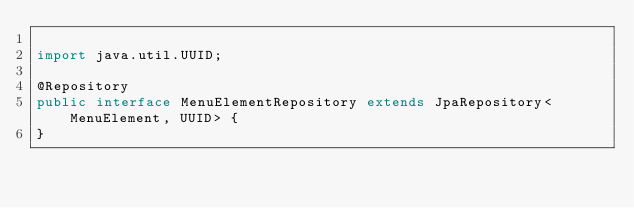<code> <loc_0><loc_0><loc_500><loc_500><_Java_>
import java.util.UUID;

@Repository
public interface MenuElementRepository extends JpaRepository<MenuElement, UUID> {
}
</code> 